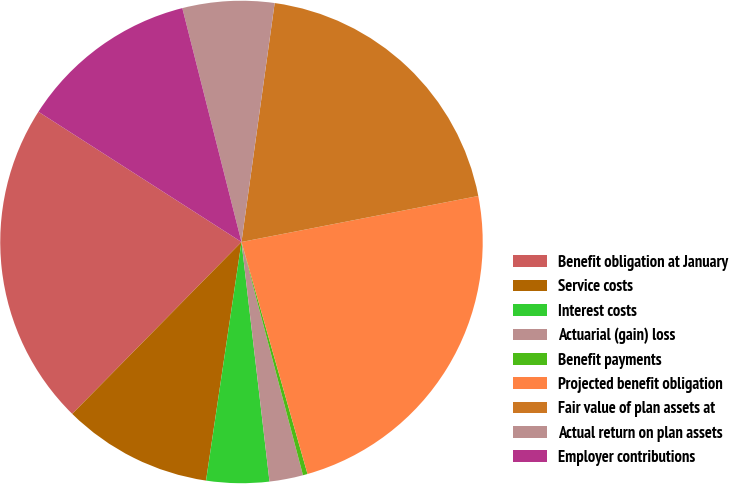Convert chart to OTSL. <chart><loc_0><loc_0><loc_500><loc_500><pie_chart><fcel>Benefit obligation at January<fcel>Service costs<fcel>Interest costs<fcel>Actuarial (gain) loss<fcel>Benefit payments<fcel>Projected benefit obligation<fcel>Fair value of plan assets at<fcel>Actual return on plan assets<fcel>Employer contributions<nl><fcel>21.7%<fcel>10.03%<fcel>4.2%<fcel>2.25%<fcel>0.31%<fcel>23.64%<fcel>19.75%<fcel>6.14%<fcel>11.98%<nl></chart> 